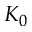<formula> <loc_0><loc_0><loc_500><loc_500>K _ { 0 }</formula> 